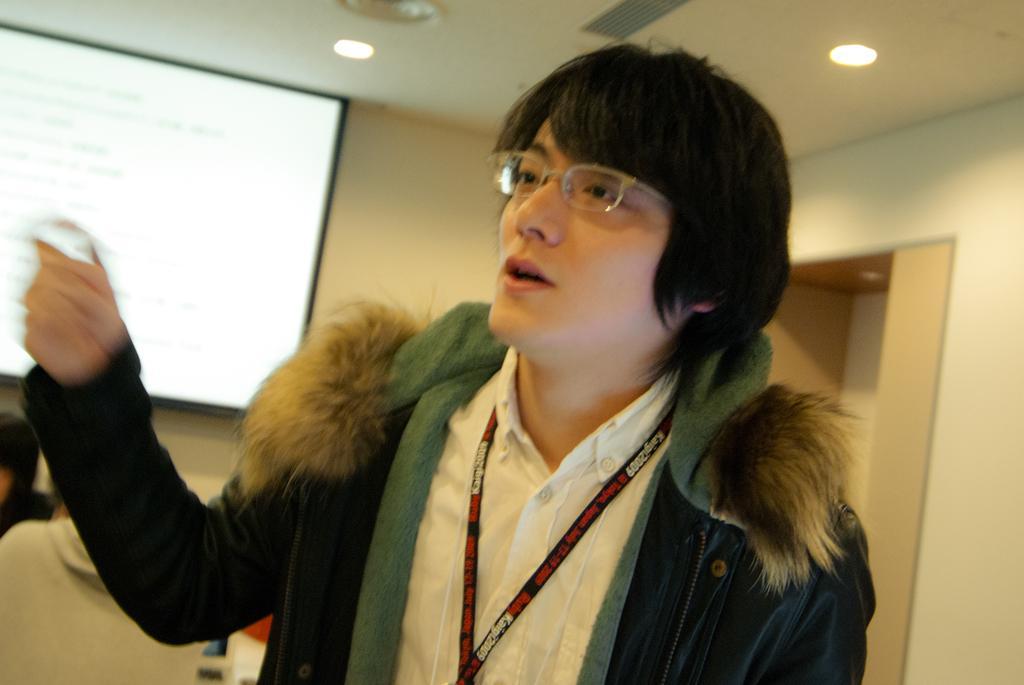How would you summarize this image in a sentence or two? In this image we can see a person wearing spectacles and behind there are few people in the room and we can see a screen on the left side of the image and there are some lights attached to the ceiling. 